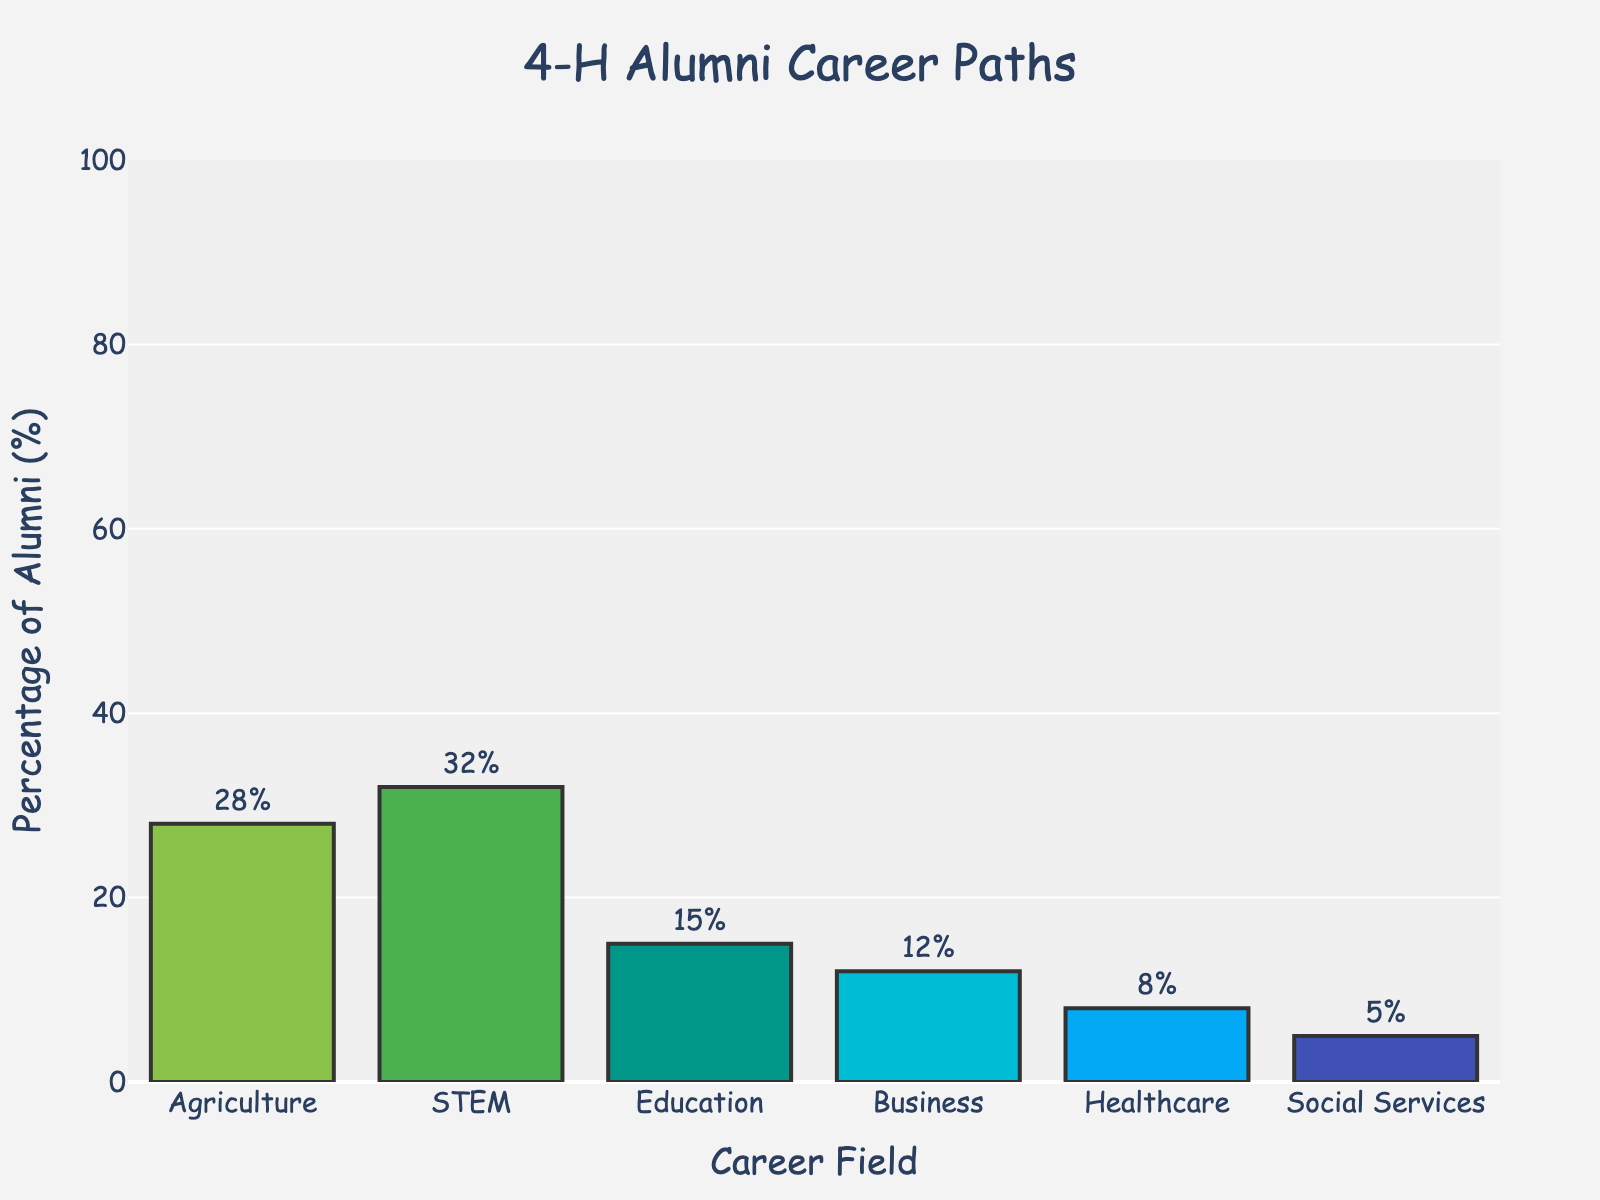Which career field has the highest percentage of 4-H alumni? Identify the tallest bar in the chart. The highest bar represents STEM with a height indicating 32%.
Answer: STEM Which career field has the lowest percentage of 4-H alumni? Identify the shortest bar in the chart. The shortest bar represents Social Services with a height indicating 5%.
Answer: Social Services What is the total percentage of 4-H alumni pursuing careers in non-STEM fields? Sum the percentages for Agriculture, Education, Business, Healthcare, and Social Services. That's 28% + 15% + 12% + 8% + 5% = 68%.
Answer: 68% How much higher is the percentage of 4-H alumni in STEM compared to those in Healthcare? Subtract the percentage for Healthcare from the percentage for STEM. That's 32% - 8% = 24%.
Answer: 24% What are the colors used to represent the career fields Agriculture and Healthcare? Look at the colors of the bars for Agriculture and Healthcare in the chart. Agriculture is represented by a light green color, and Healthcare is represented by a blue color.
Answer: Light green for Agriculture, blue for Healthcare What is the combined percentage of 4-H alumni working in Agriculture and Business? Sum the percentages for Agriculture and Business. That's 28% + 12% = 40%.
Answer: 40% How does the percentage of 4-H alumni in Education compare to those in Business? Compare the heights of the bars for Education and Business. Education has 15%, which is higher than Business with 12%.
Answer: Education has a higher percentage Which two career fields have the closest percentages of 4-H alumni? Compare the percentages for all career fields and find the two with the smallest difference. Education (15%) and Business (12%) are closest, with a difference of 3%.
Answer: Education and Business What visual element indicates the percentage values next to each bar? Observe the small numbers shown outside each bar in the chart. These numbers represent the percentage values.
Answer: Numbers outside each bar Describe the background and watermark used in the chart. The chart has a light grayish background with a faint 4-H clover watermark in the center.
Answer: Light gray background, 4-H clover watermark in the center 